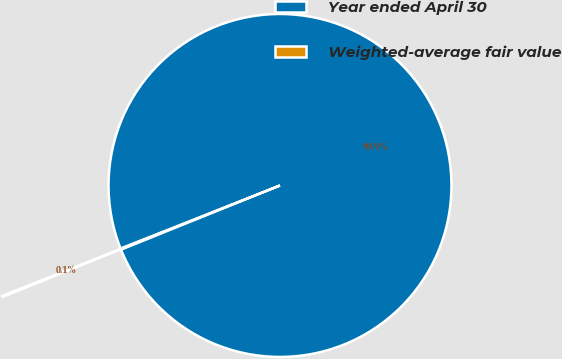<chart> <loc_0><loc_0><loc_500><loc_500><pie_chart><fcel>Year ended April 30<fcel>Weighted-average fair value<nl><fcel>99.89%<fcel>0.11%<nl></chart> 